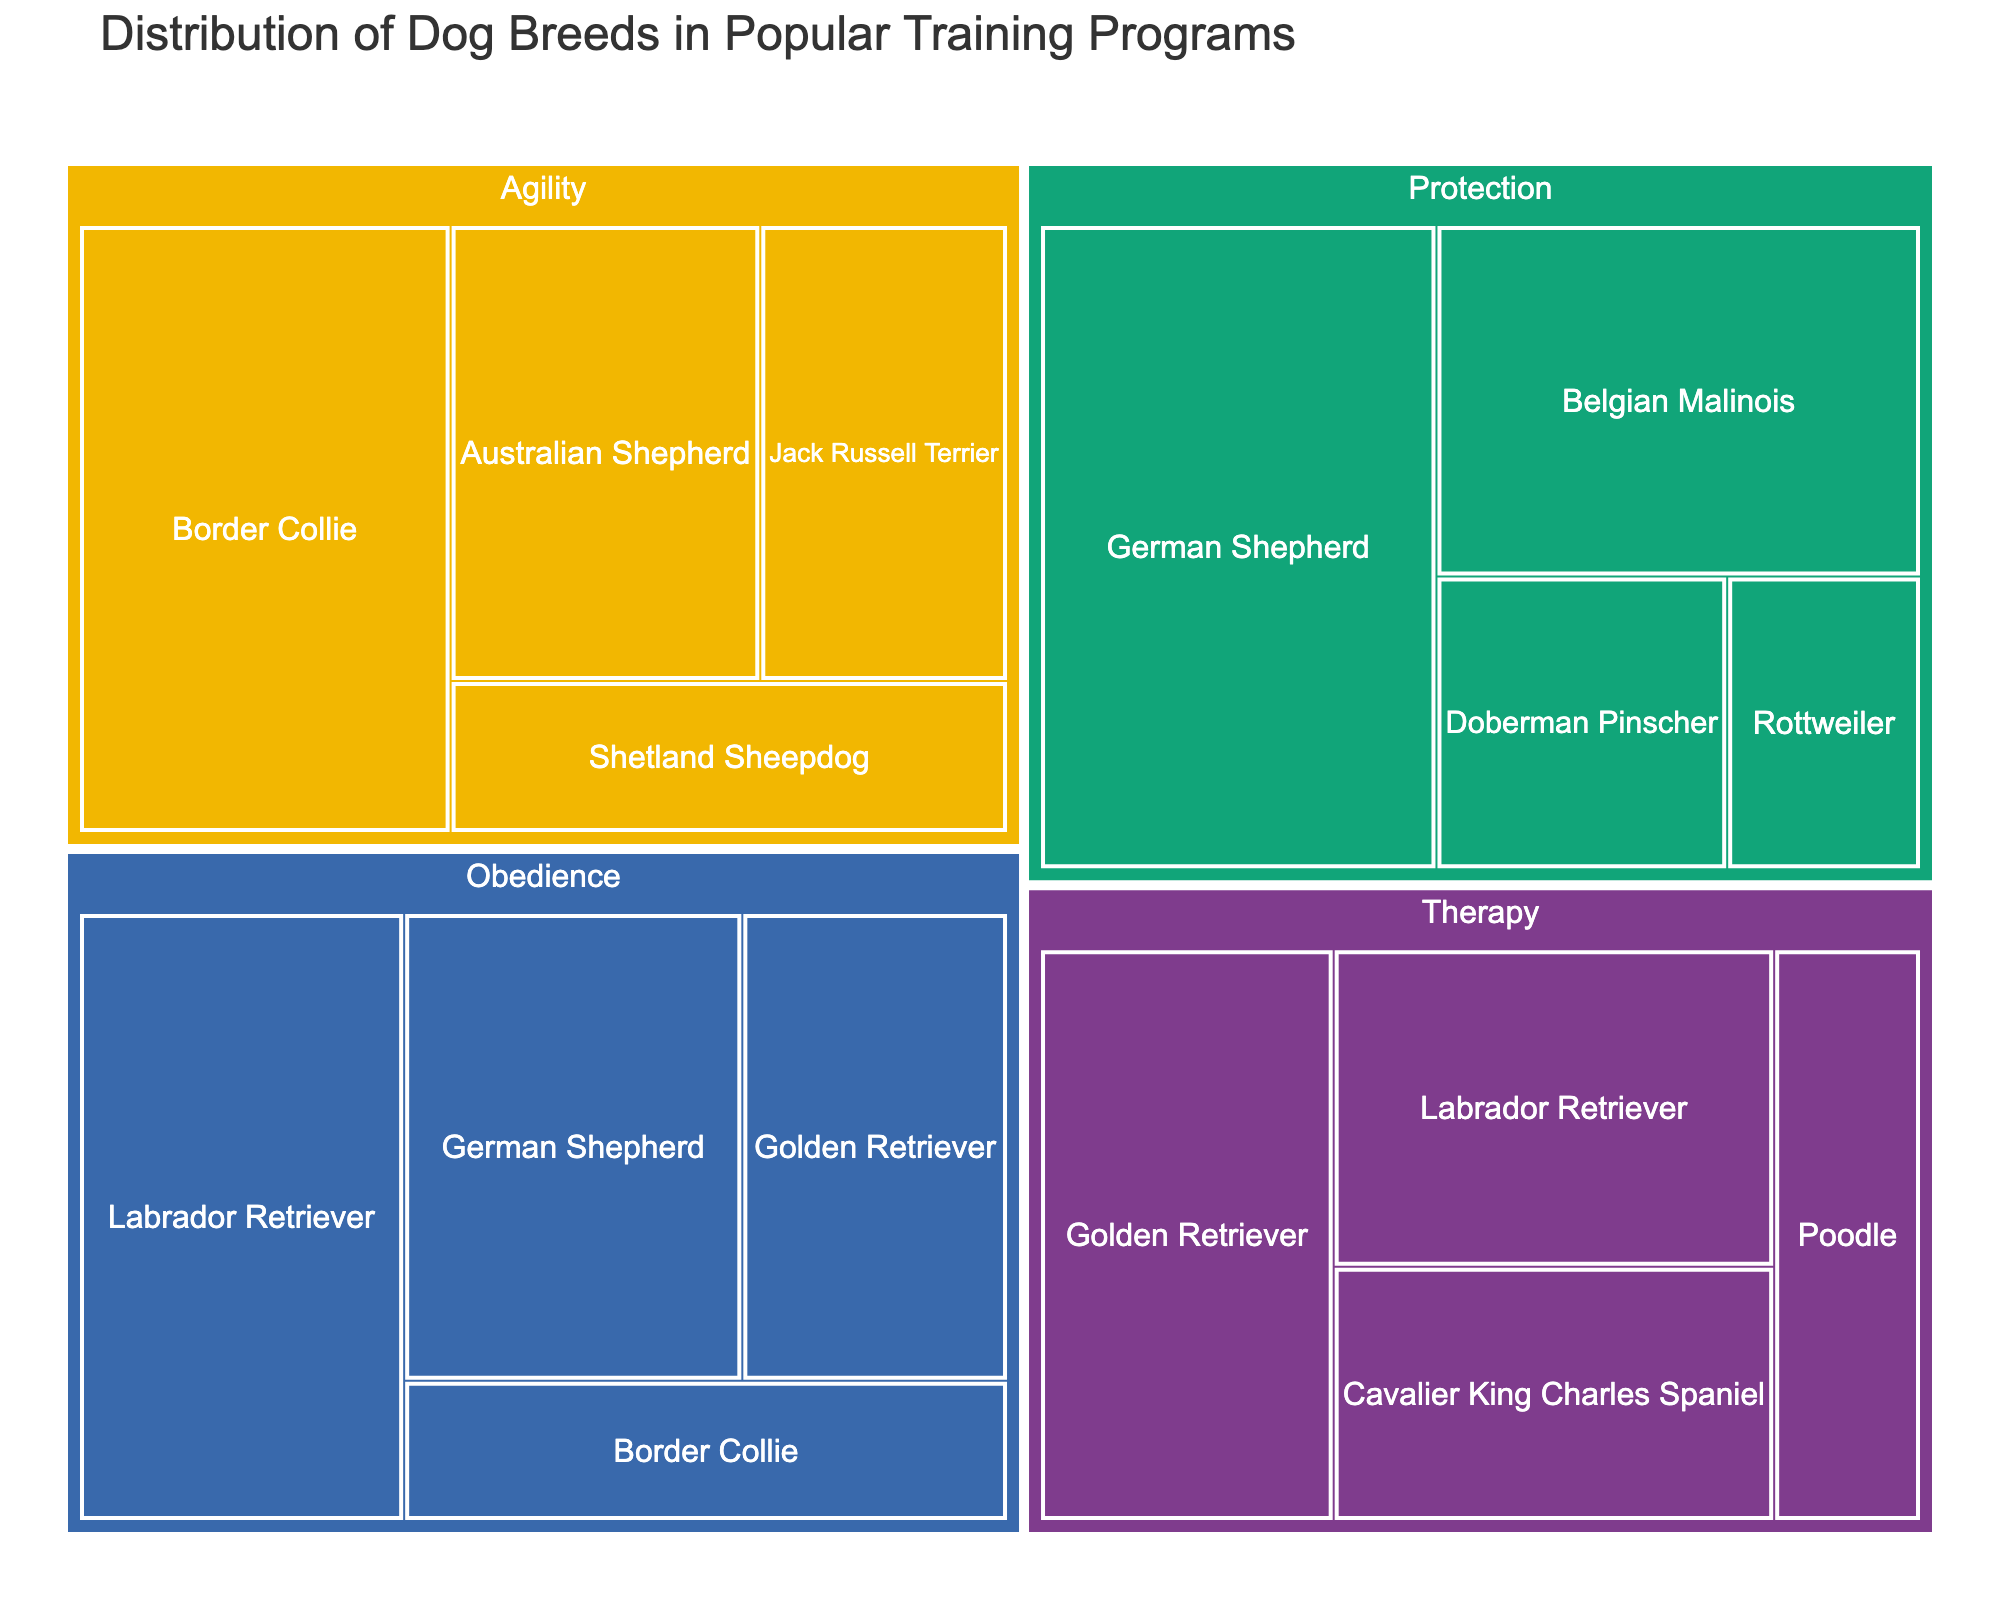What is the title of the figure? The title is prominently displayed at the top of the treemap, usually in a larger and bolder font than other text elements.
Answer: Distribution of Dog Breeds in Popular Training Programs Which breed is the most popular in the Agility category? Look for the largest rectangle within the Agility section of the treemap. The size of the rectangles represents popularity.
Answer: Border Collie How does the popularity of the Labrador Retriever in the Obedience category compare to its popularity in the Therapy category? Identify the size of the rectangles for Labrador Retriever within both the Obedience and Therapy categories. Then compare the numbers shown.
Answer: More popular in Obedience (35 vs 25) What is the combined popularity of Golden Retrievers across all categories? Locate the Golden Retriever in each category and sum the popularity values. Golden Retrievers appear in Obedience (22) and Therapy (30).
Answer: 22 + 30 = 52 Which category has the highest popularity for German Shepherds? Identify the rectangles for German Shepherds in each category and compare their sizes and numerical popularity.
Answer: Protection (45) Between the Poodle and Cavalier King Charles Spaniel in the Therapy category, which breed has higher popularity? Find the rectangles for both breeds within the Therapy category and compare the numbers.
Answer: Cavalier King Charles Spaniel (20 vs 15) What is the total popularity of the breeds in the Protection category? Sum the popularity values of all breeds in the Protection category: German Shepherd (45), Belgian Malinois (30), Doberman Pinscher (15), and Rottweiler (10).
Answer: 45 + 30 + 15 + 10 = 100 Which breed is popular across more than one category? Identify any breeds that appear in multiple categories by comparing the breed names across categories.
Answer: Labrador Retriever, German Shepherd, Golden Retriever, Border Collie How many breeds are represented in the Agility category? Count the number of unique breed names listed under the Agility category.
Answer: 4 Which category has the most diverse representation of breeds? Compare the number of unique breeds across each category to determine which has the most distinct breeds.
Answer: Obedience and Protection (both have 4) 